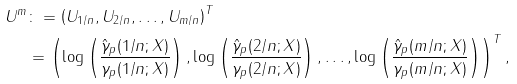<formula> <loc_0><loc_0><loc_500><loc_500>U ^ { m } & \colon = \left ( U _ { 1 / n } , U _ { 2 / n } , \dots , U _ { m / n } \right ) ^ { T } \\ & = \left ( \log \left ( \frac { \hat { \gamma } _ { p } ( 1 / n ; X ) } { \gamma _ { p } ( 1 / n ; X ) } \right ) , \log \left ( \frac { \hat { \gamma } _ { p } ( 2 / n ; X ) } { \gamma _ { p } ( 2 / n ; X ) } \right ) , \dots , \log \left ( \frac { \hat { \gamma } _ { p } ( m / n ; X ) } { \gamma _ { p } ( m / n ; X ) } \right ) \right ) ^ { T } ,</formula> 